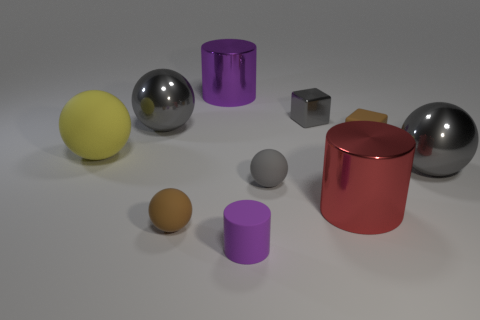What is the material of the cylinder that is both behind the tiny purple object and in front of the small gray shiny thing?
Offer a very short reply. Metal. There is a large metal object on the left side of the brown matte object in front of the big red object; what shape is it?
Ensure brevity in your answer.  Sphere. Is there anything else of the same color as the small matte cylinder?
Offer a terse response. Yes. There is a purple matte object; is its size the same as the cylinder that is behind the large red metal cylinder?
Keep it short and to the point. No. How many big things are purple rubber things or brown matte balls?
Ensure brevity in your answer.  0. Are there more large blue matte cubes than large yellow rubber spheres?
Give a very brief answer. No. What number of gray metallic things are right of the brown matte object that is on the right side of the big cylinder that is left of the small purple matte thing?
Offer a terse response. 1. What is the shape of the small gray rubber thing?
Offer a very short reply. Sphere. What number of other things are made of the same material as the small purple cylinder?
Your answer should be very brief. 4. Do the yellow matte object and the purple matte thing have the same size?
Your response must be concise. No. 